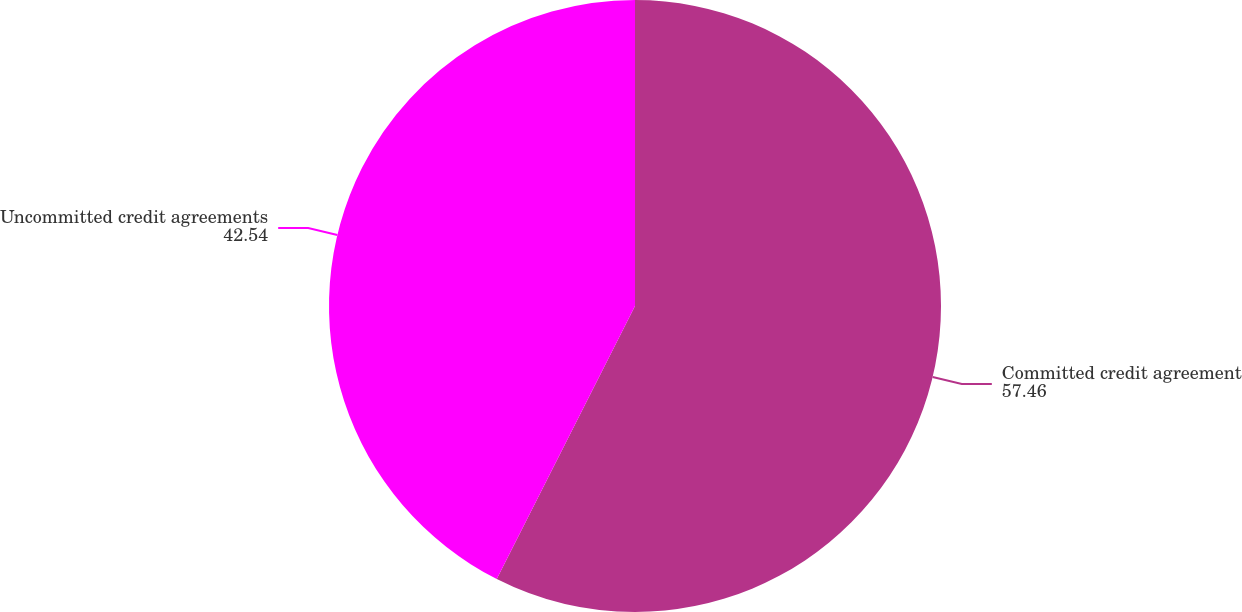Convert chart to OTSL. <chart><loc_0><loc_0><loc_500><loc_500><pie_chart><fcel>Committed credit agreement<fcel>Uncommitted credit agreements<nl><fcel>57.46%<fcel>42.54%<nl></chart> 